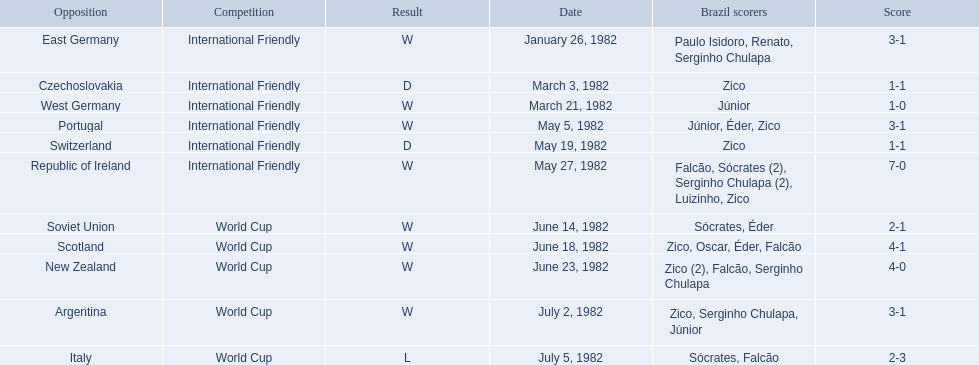Who did brazil play against Soviet Union. Who scored the most goals? Portugal. 